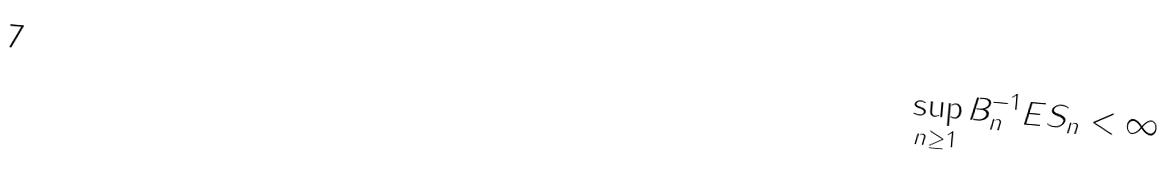Convert formula to latex. <formula><loc_0><loc_0><loc_500><loc_500>\sup _ { n \geq 1 } B _ { n } ^ { - 1 } E \| S _ { n } \| < \infty \,</formula> 